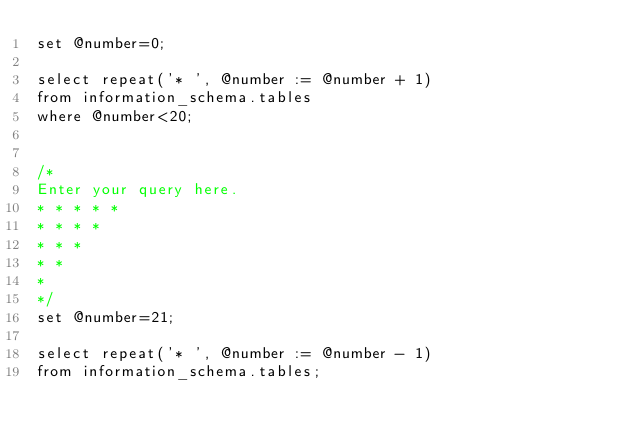<code> <loc_0><loc_0><loc_500><loc_500><_SQL_>set @number=0;

select repeat('* ', @number := @number + 1) 
from information_schema.tables
where @number<20;


/*
Enter your query here.
* * * * * 
* * * * 
* * * 
* * 
*
*/
set @number=21;

select repeat('* ', @number := @number - 1) 
from information_schema.tables;</code> 